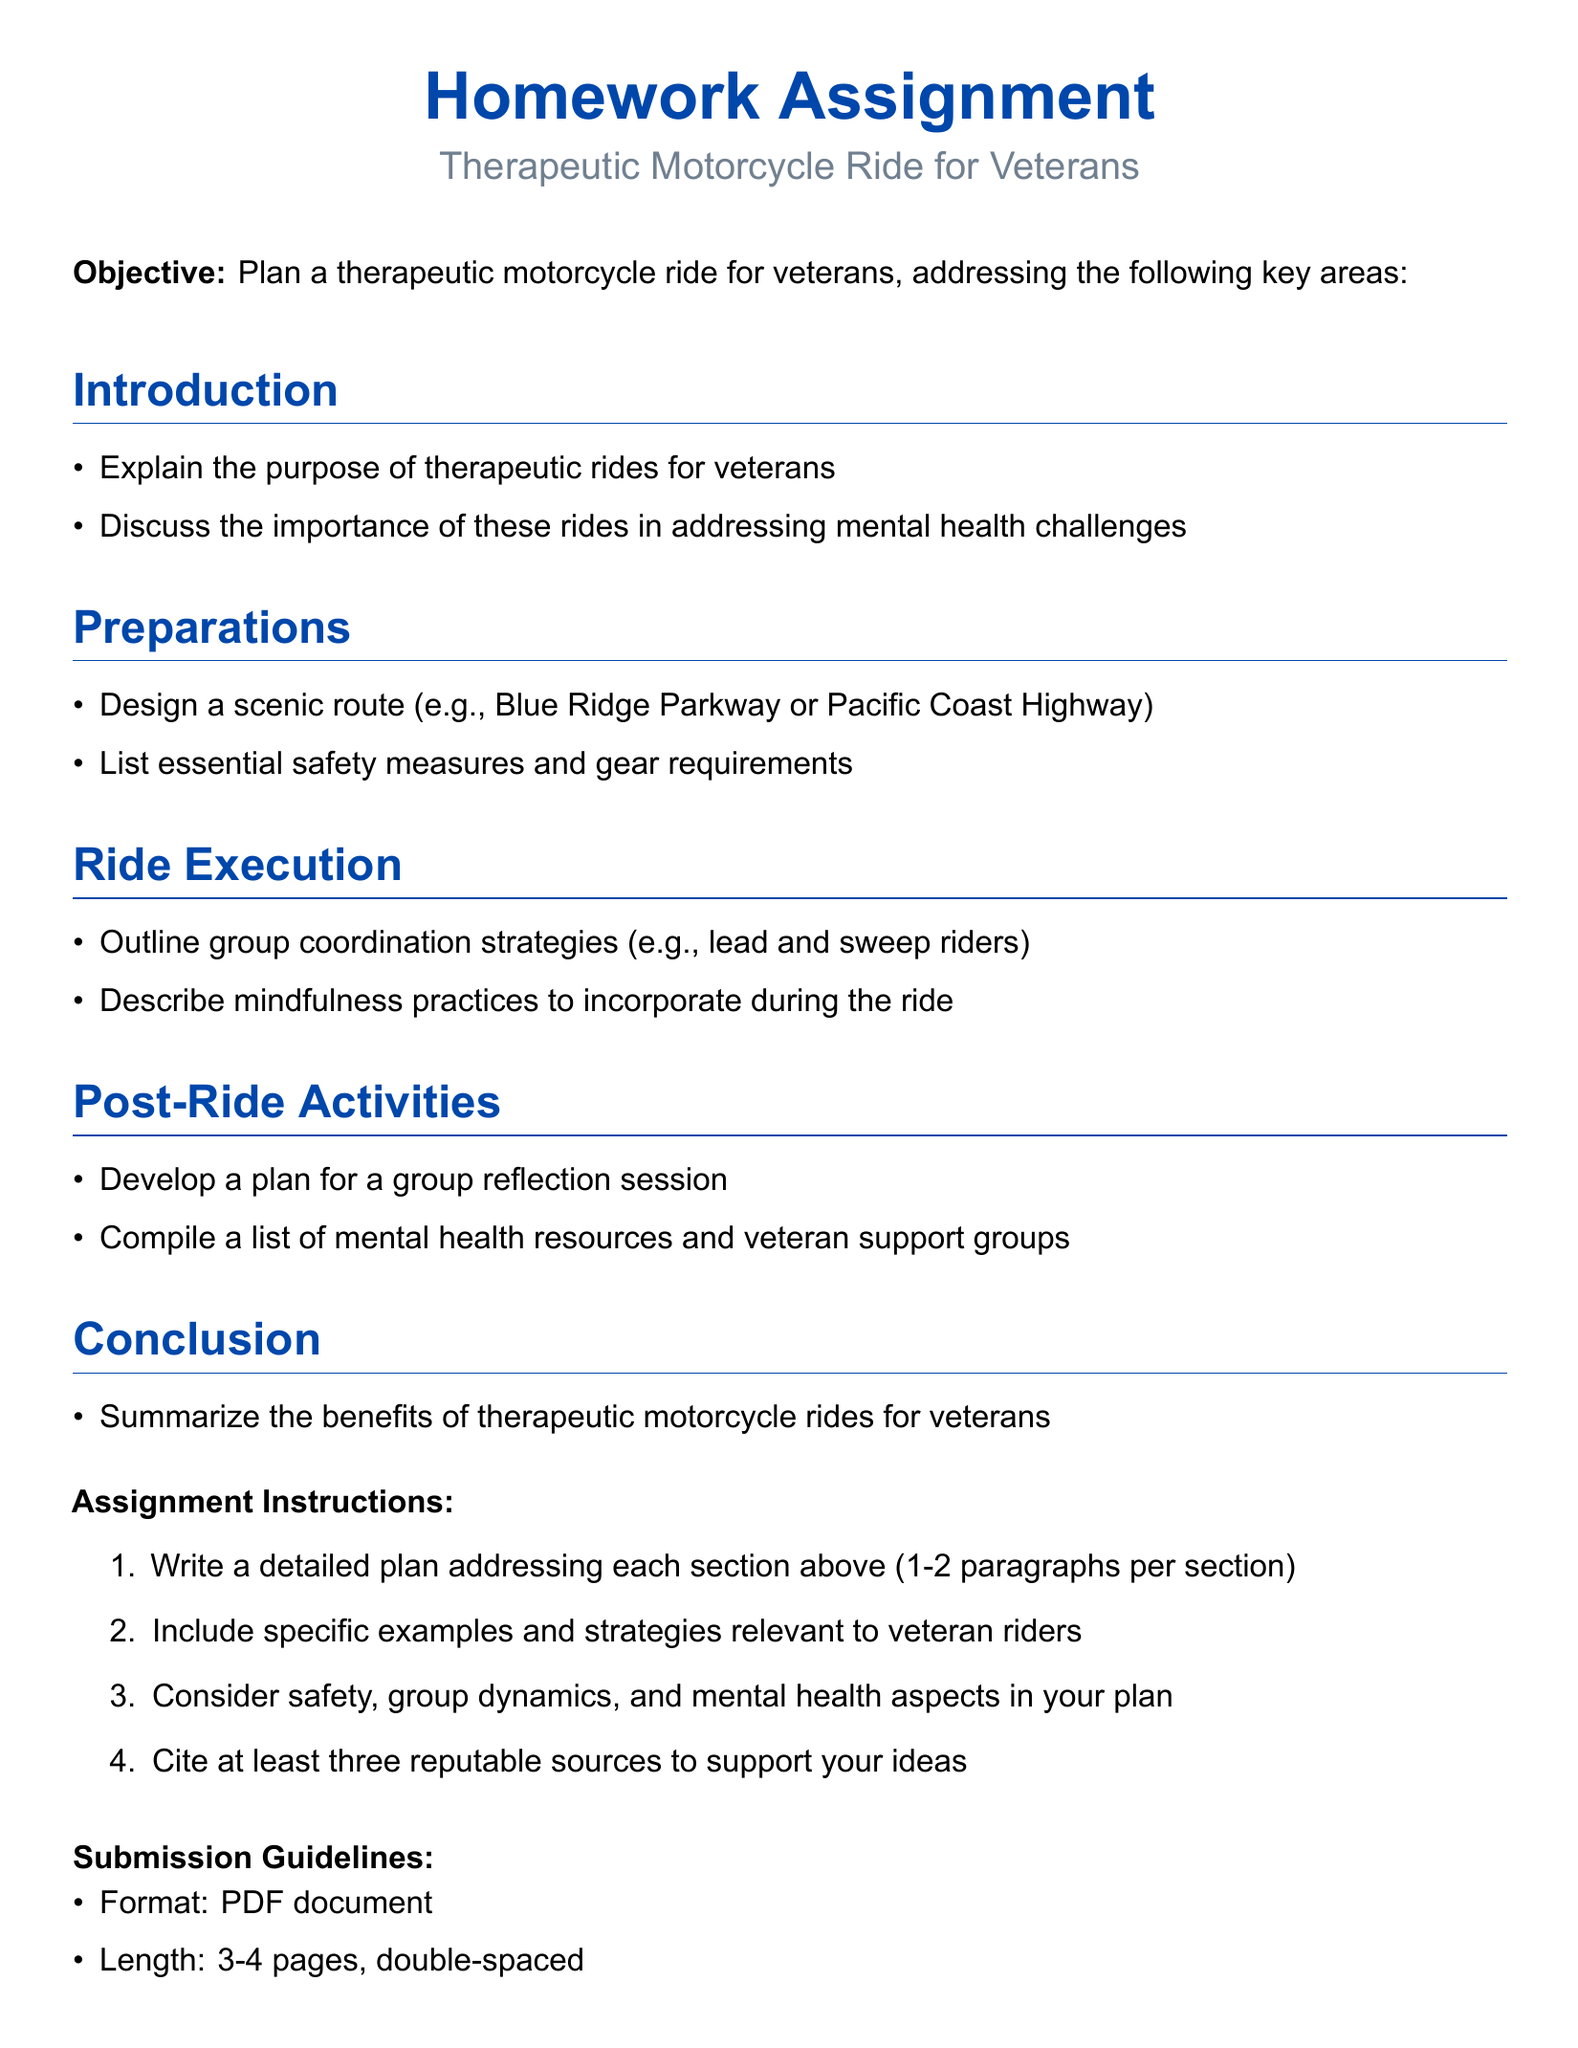what is the title of the document? The title is prominently displayed at the center of the document, which is "Homework Assignment".
Answer: Homework Assignment what is the purpose of therapeutic rides for veterans? The document outlines that the purpose is to address mental health challenges faced by veterans.
Answer: Address mental health challenges what is one example of a scenic route mentioned? The document states the Blue Ridge Parkway or Pacific Coast Highway as examples of scenic routes.
Answer: Blue Ridge Parkway how many paragraphs should each section include? The assignment instructions specify that each section should consist of 1-2 paragraphs.
Answer: 1-2 paragraphs what color is used for the title text? The title text uses the color motorcycle blue, as defined in the document.
Answer: motorcycle blue what is one safety measure listed in the preparation section? The document requires listing essential safety measures in the preparations section, but a specific measure is not directly stated.
Answer: Essential safety measures what are participants encouraged to reflect on after the ride? The document mentions a group reflection session as a post-ride activity for participants.
Answer: Group reflection session how should the submission document be formatted? The submission should be formatted as a PDF document, per the guidelines in the document.
Answer: PDF document what is the due date for the assignment? The due date is indicated as "[Insert due date]", which means it needs to be specified.
Answer: [Insert due date] 